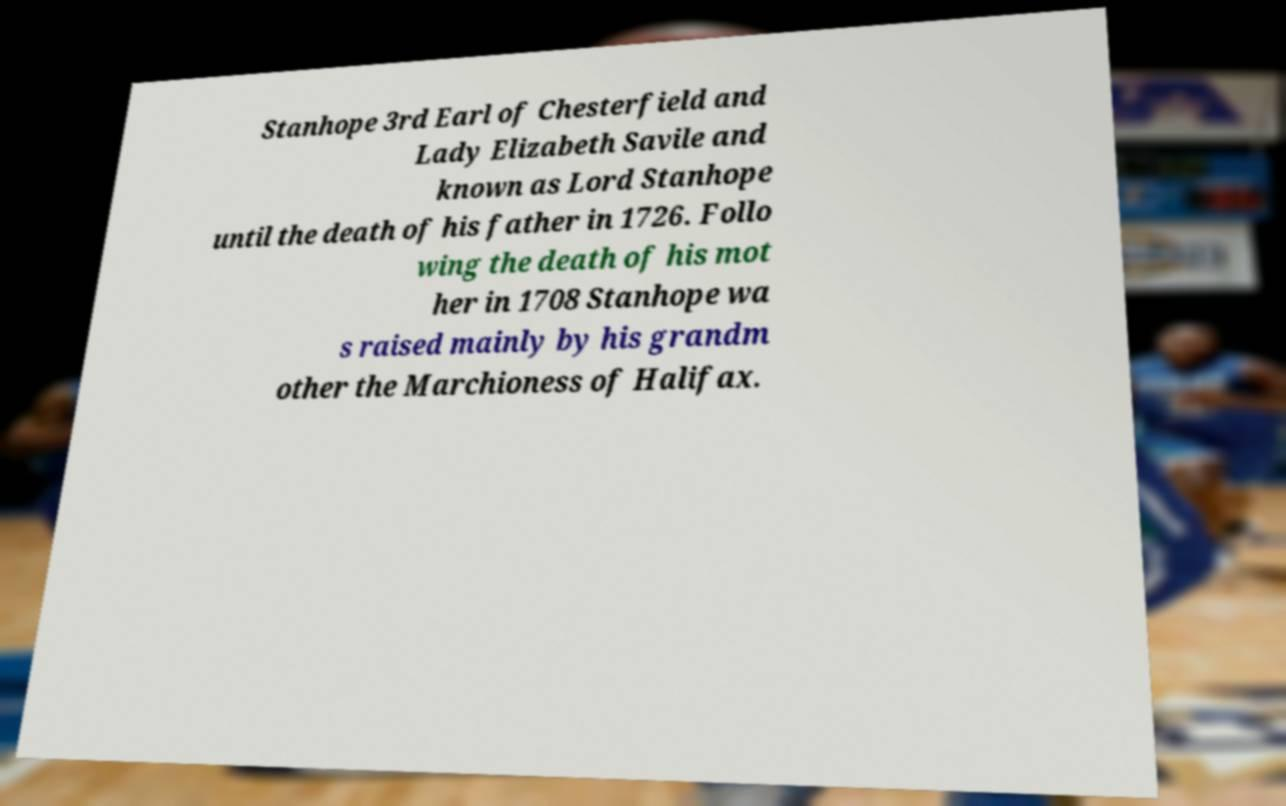Please identify and transcribe the text found in this image. Stanhope 3rd Earl of Chesterfield and Lady Elizabeth Savile and known as Lord Stanhope until the death of his father in 1726. Follo wing the death of his mot her in 1708 Stanhope wa s raised mainly by his grandm other the Marchioness of Halifax. 